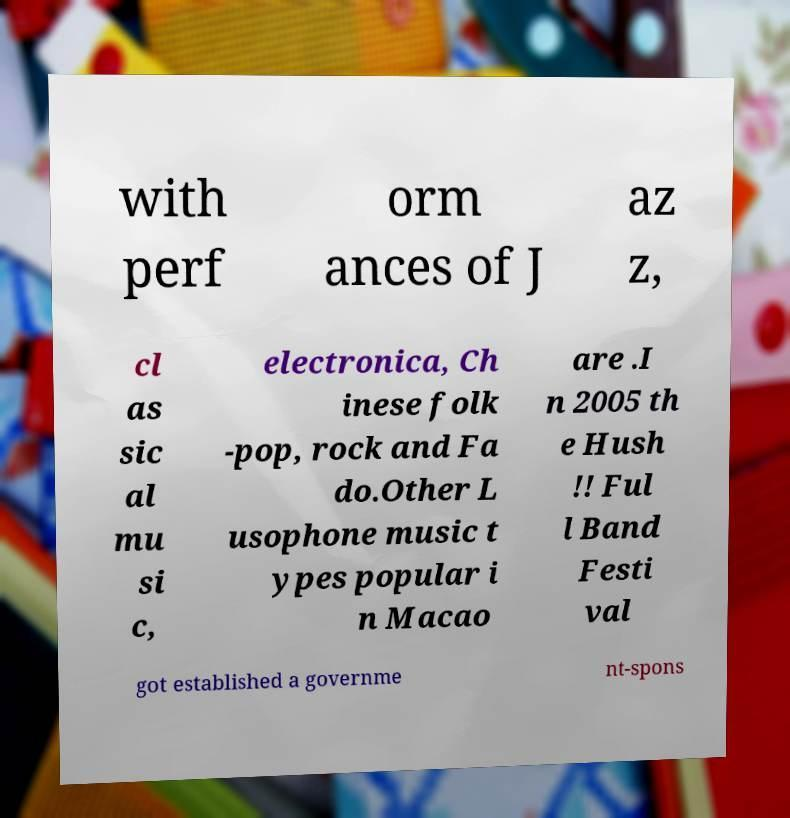There's text embedded in this image that I need extracted. Can you transcribe it verbatim? with perf orm ances of J az z, cl as sic al mu si c, electronica, Ch inese folk -pop, rock and Fa do.Other L usophone music t ypes popular i n Macao are .I n 2005 th e Hush !! Ful l Band Festi val got established a governme nt-spons 